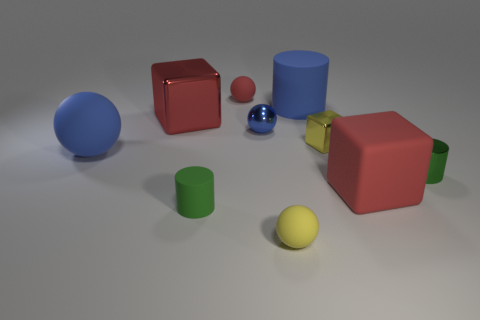The big red thing right of the large rubber cylinder has what shape? The big red object to the right of the large rubber cylinder is a cube, defined by its six equal square faces and right-angled edges. 